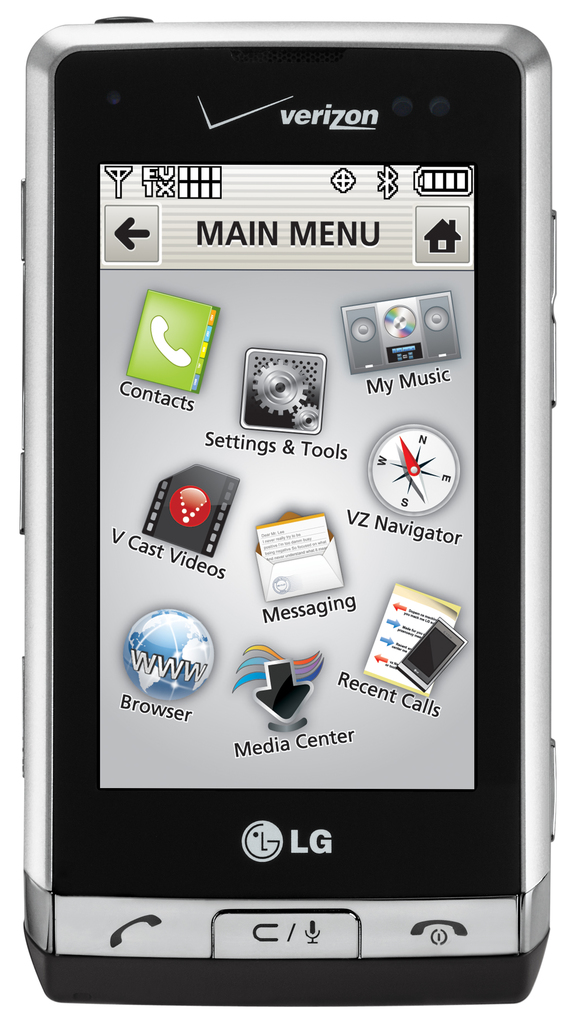Can you tell me more about the phone's manufacturer and what era this model represents? This phone is manufactured by LG, known for its electronics and telecommunications products. The model shown represents the era of feature phones prominent in the late 2000s, characterized by their multimedia capabilities and the beginning integration of advanced internet services in a non-smartphone format. 